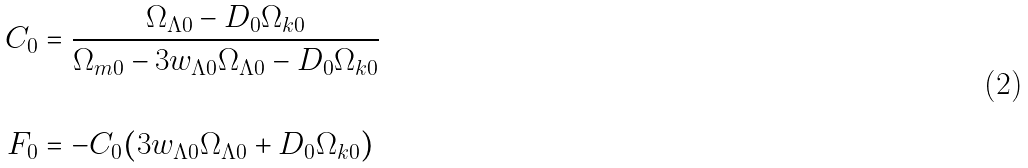<formula> <loc_0><loc_0><loc_500><loc_500>C _ { 0 } & = \frac { \Omega _ { \Lambda 0 } - D _ { 0 } \Omega _ { k 0 } } { \Omega _ { m 0 } - 3 w _ { \Lambda 0 } \Omega _ { \Lambda 0 } - D _ { 0 } \Omega _ { k 0 } } \\ & \\ F _ { 0 } & = - C _ { 0 } ( 3 w _ { \Lambda 0 } \Omega _ { \Lambda 0 } + D _ { 0 } \Omega _ { k 0 } ) \\</formula> 